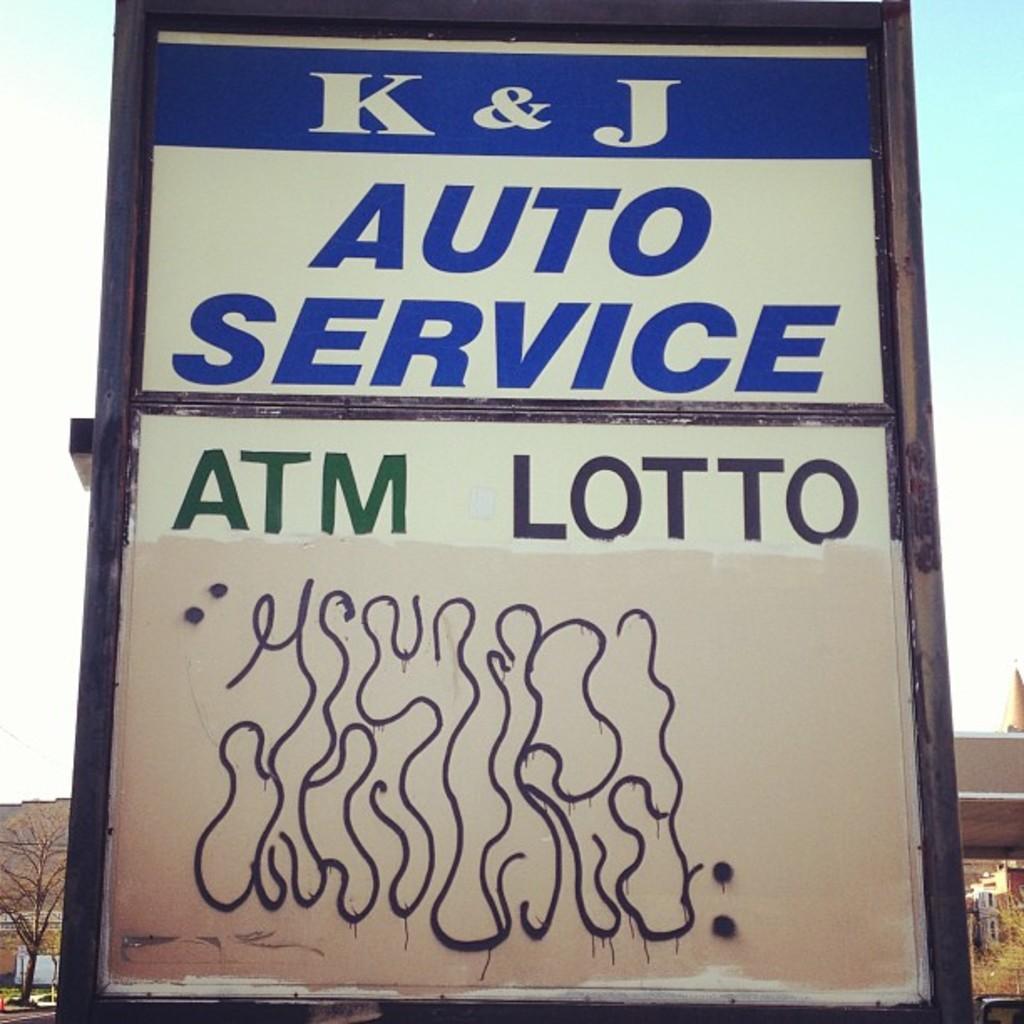Describe this image in one or two sentences. In this image we can see a display board on with "K & J Auto services and A T M lotto" is displayed. 